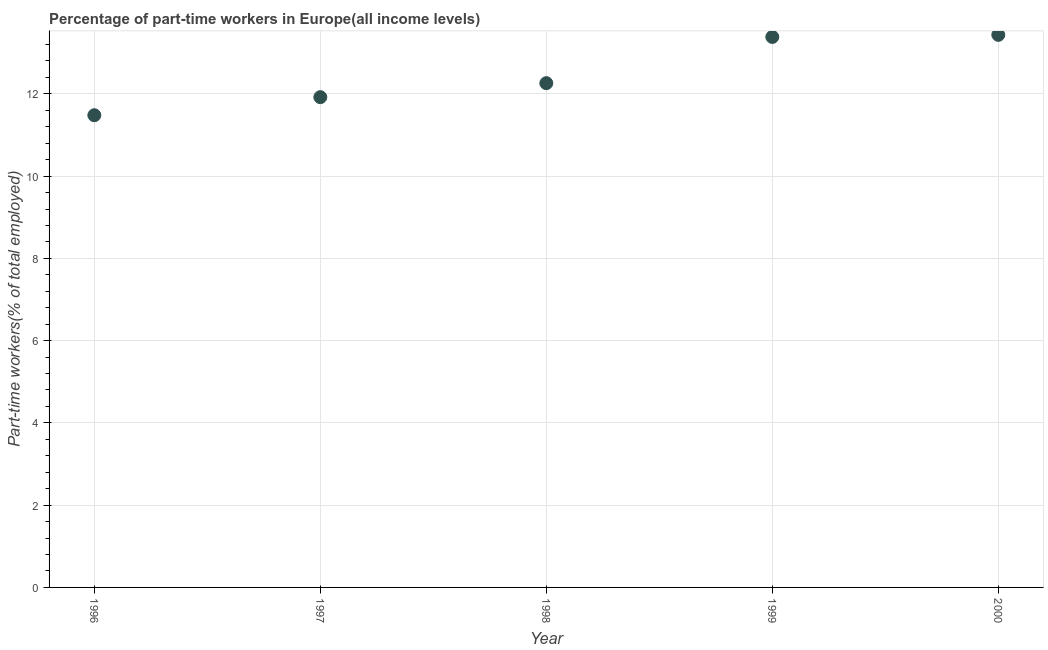What is the percentage of part-time workers in 1999?
Your answer should be very brief. 13.38. Across all years, what is the maximum percentage of part-time workers?
Offer a very short reply. 13.43. Across all years, what is the minimum percentage of part-time workers?
Provide a succinct answer. 11.48. In which year was the percentage of part-time workers minimum?
Your response must be concise. 1996. What is the sum of the percentage of part-time workers?
Ensure brevity in your answer.  62.48. What is the difference between the percentage of part-time workers in 1996 and 1999?
Provide a succinct answer. -1.9. What is the average percentage of part-time workers per year?
Keep it short and to the point. 12.5. What is the median percentage of part-time workers?
Your response must be concise. 12.26. What is the ratio of the percentage of part-time workers in 1997 to that in 1999?
Provide a succinct answer. 0.89. Is the percentage of part-time workers in 1996 less than that in 1999?
Keep it short and to the point. Yes. Is the difference between the percentage of part-time workers in 1996 and 1998 greater than the difference between any two years?
Keep it short and to the point. No. What is the difference between the highest and the second highest percentage of part-time workers?
Give a very brief answer. 0.05. What is the difference between the highest and the lowest percentage of part-time workers?
Give a very brief answer. 1.95. How many dotlines are there?
Provide a succinct answer. 1. What is the difference between two consecutive major ticks on the Y-axis?
Your answer should be compact. 2. Are the values on the major ticks of Y-axis written in scientific E-notation?
Offer a very short reply. No. What is the title of the graph?
Offer a terse response. Percentage of part-time workers in Europe(all income levels). What is the label or title of the X-axis?
Provide a succinct answer. Year. What is the label or title of the Y-axis?
Offer a very short reply. Part-time workers(% of total employed). What is the Part-time workers(% of total employed) in 1996?
Provide a succinct answer. 11.48. What is the Part-time workers(% of total employed) in 1997?
Provide a short and direct response. 11.92. What is the Part-time workers(% of total employed) in 1998?
Provide a succinct answer. 12.26. What is the Part-time workers(% of total employed) in 1999?
Your answer should be very brief. 13.38. What is the Part-time workers(% of total employed) in 2000?
Offer a very short reply. 13.43. What is the difference between the Part-time workers(% of total employed) in 1996 and 1997?
Your response must be concise. -0.44. What is the difference between the Part-time workers(% of total employed) in 1996 and 1998?
Give a very brief answer. -0.78. What is the difference between the Part-time workers(% of total employed) in 1996 and 1999?
Offer a terse response. -1.9. What is the difference between the Part-time workers(% of total employed) in 1996 and 2000?
Provide a succinct answer. -1.95. What is the difference between the Part-time workers(% of total employed) in 1997 and 1998?
Make the answer very short. -0.34. What is the difference between the Part-time workers(% of total employed) in 1997 and 1999?
Your answer should be very brief. -1.46. What is the difference between the Part-time workers(% of total employed) in 1997 and 2000?
Offer a terse response. -1.52. What is the difference between the Part-time workers(% of total employed) in 1998 and 1999?
Give a very brief answer. -1.12. What is the difference between the Part-time workers(% of total employed) in 1998 and 2000?
Offer a terse response. -1.17. What is the difference between the Part-time workers(% of total employed) in 1999 and 2000?
Give a very brief answer. -0.05. What is the ratio of the Part-time workers(% of total employed) in 1996 to that in 1998?
Ensure brevity in your answer.  0.94. What is the ratio of the Part-time workers(% of total employed) in 1996 to that in 1999?
Your answer should be very brief. 0.86. What is the ratio of the Part-time workers(% of total employed) in 1996 to that in 2000?
Your answer should be very brief. 0.85. What is the ratio of the Part-time workers(% of total employed) in 1997 to that in 1998?
Keep it short and to the point. 0.97. What is the ratio of the Part-time workers(% of total employed) in 1997 to that in 1999?
Give a very brief answer. 0.89. What is the ratio of the Part-time workers(% of total employed) in 1997 to that in 2000?
Your answer should be compact. 0.89. What is the ratio of the Part-time workers(% of total employed) in 1998 to that in 1999?
Make the answer very short. 0.92. What is the ratio of the Part-time workers(% of total employed) in 1998 to that in 2000?
Your answer should be very brief. 0.91. What is the ratio of the Part-time workers(% of total employed) in 1999 to that in 2000?
Make the answer very short. 1. 